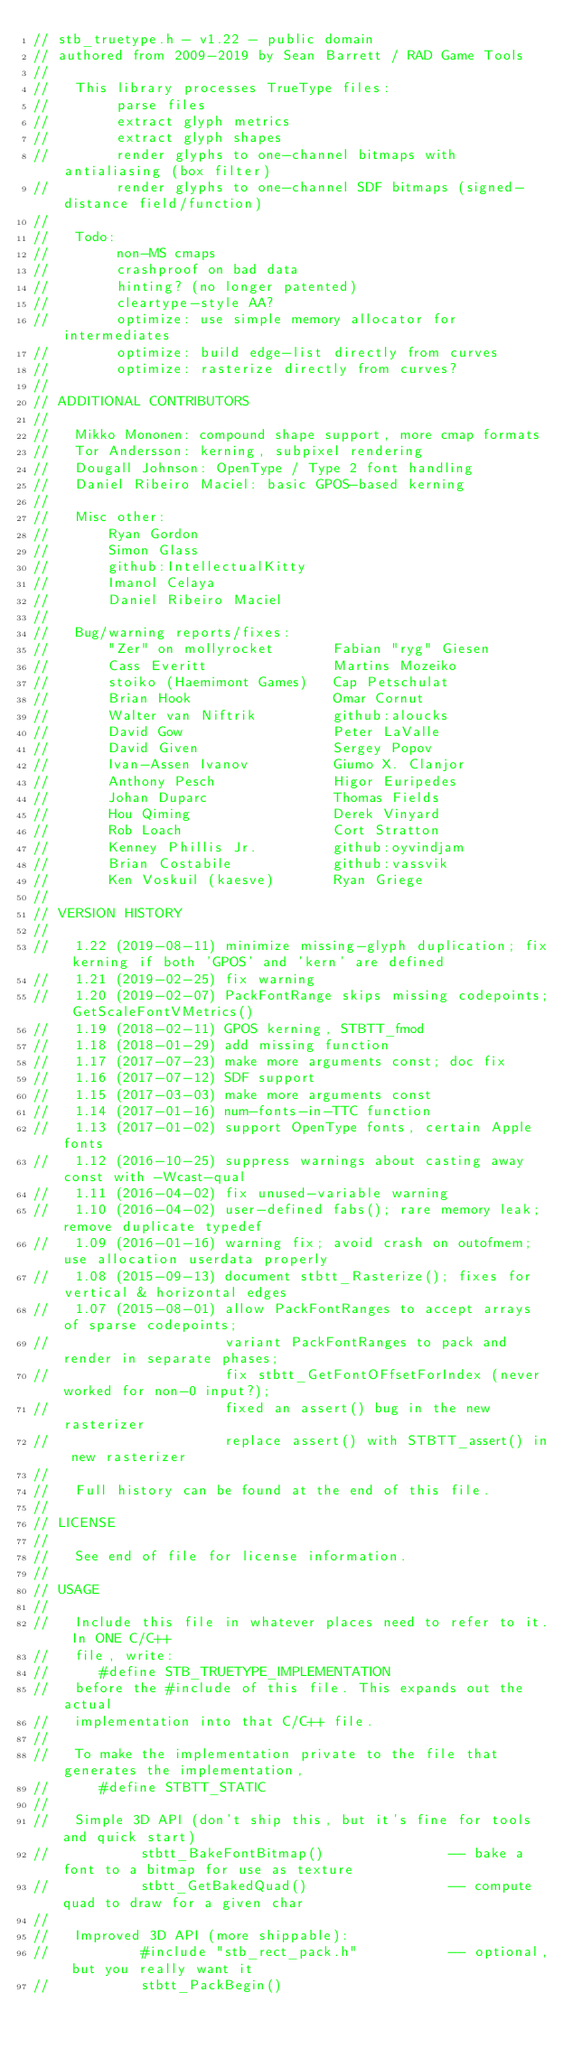Convert code to text. <code><loc_0><loc_0><loc_500><loc_500><_C_>// stb_truetype.h - v1.22 - public domain
// authored from 2009-2019 by Sean Barrett / RAD Game Tools
//
//   This library processes TrueType files:
//        parse files
//        extract glyph metrics
//        extract glyph shapes
//        render glyphs to one-channel bitmaps with antialiasing (box filter)
//        render glyphs to one-channel SDF bitmaps (signed-distance field/function)
//
//   Todo:
//        non-MS cmaps
//        crashproof on bad data
//        hinting? (no longer patented)
//        cleartype-style AA?
//        optimize: use simple memory allocator for intermediates
//        optimize: build edge-list directly from curves
//        optimize: rasterize directly from curves?
//
// ADDITIONAL CONTRIBUTORS
//
//   Mikko Mononen: compound shape support, more cmap formats
//   Tor Andersson: kerning, subpixel rendering
//   Dougall Johnson: OpenType / Type 2 font handling
//   Daniel Ribeiro Maciel: basic GPOS-based kerning
//
//   Misc other:
//       Ryan Gordon
//       Simon Glass
//       github:IntellectualKitty
//       Imanol Celaya
//       Daniel Ribeiro Maciel
//
//   Bug/warning reports/fixes:
//       "Zer" on mollyrocket       Fabian "ryg" Giesen
//       Cass Everitt               Martins Mozeiko
//       stoiko (Haemimont Games)   Cap Petschulat
//       Brian Hook                 Omar Cornut
//       Walter van Niftrik         github:aloucks
//       David Gow                  Peter LaValle
//       David Given                Sergey Popov
//       Ivan-Assen Ivanov          Giumo X. Clanjor
//       Anthony Pesch              Higor Euripedes
//       Johan Duparc               Thomas Fields
//       Hou Qiming                 Derek Vinyard
//       Rob Loach                  Cort Stratton
//       Kenney Phillis Jr.         github:oyvindjam
//       Brian Costabile            github:vassvik
//       Ken Voskuil (kaesve)       Ryan Griege
//       
// VERSION HISTORY
//
//   1.22 (2019-08-11) minimize missing-glyph duplication; fix kerning if both 'GPOS' and 'kern' are defined 
//   1.21 (2019-02-25) fix warning
//   1.20 (2019-02-07) PackFontRange skips missing codepoints; GetScaleFontVMetrics()
//   1.19 (2018-02-11) GPOS kerning, STBTT_fmod
//   1.18 (2018-01-29) add missing function
//   1.17 (2017-07-23) make more arguments const; doc fix
//   1.16 (2017-07-12) SDF support
//   1.15 (2017-03-03) make more arguments const
//   1.14 (2017-01-16) num-fonts-in-TTC function
//   1.13 (2017-01-02) support OpenType fonts, certain Apple fonts
//   1.12 (2016-10-25) suppress warnings about casting away const with -Wcast-qual
//   1.11 (2016-04-02) fix unused-variable warning
//   1.10 (2016-04-02) user-defined fabs(); rare memory leak; remove duplicate typedef
//   1.09 (2016-01-16) warning fix; avoid crash on outofmem; use allocation userdata properly
//   1.08 (2015-09-13) document stbtt_Rasterize(); fixes for vertical & horizontal edges
//   1.07 (2015-08-01) allow PackFontRanges to accept arrays of sparse codepoints;
//                     variant PackFontRanges to pack and render in separate phases;
//                     fix stbtt_GetFontOFfsetForIndex (never worked for non-0 input?);
//                     fixed an assert() bug in the new rasterizer
//                     replace assert() with STBTT_assert() in new rasterizer
//
//   Full history can be found at the end of this file.
//
// LICENSE
//
//   See end of file for license information.
//
// USAGE
//
//   Include this file in whatever places need to refer to it. In ONE C/C++
//   file, write:
//      #define STB_TRUETYPE_IMPLEMENTATION
//   before the #include of this file. This expands out the actual
//   implementation into that C/C++ file.
//
//   To make the implementation private to the file that generates the implementation,
//      #define STBTT_STATIC
//
//   Simple 3D API (don't ship this, but it's fine for tools and quick start)
//           stbtt_BakeFontBitmap()               -- bake a font to a bitmap for use as texture
//           stbtt_GetBakedQuad()                 -- compute quad to draw for a given char
//
//   Improved 3D API (more shippable):
//           #include "stb_rect_pack.h"           -- optional, but you really want it
//           stbtt_PackBegin()</code> 